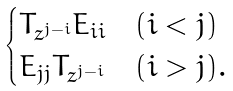<formula> <loc_0><loc_0><loc_500><loc_500>\begin{cases} T _ { z ^ { j - i } } E _ { i i } & ( i < j ) \\ E _ { j j } T _ { z ^ { j - i } } & ( i > j ) . \end{cases}</formula> 